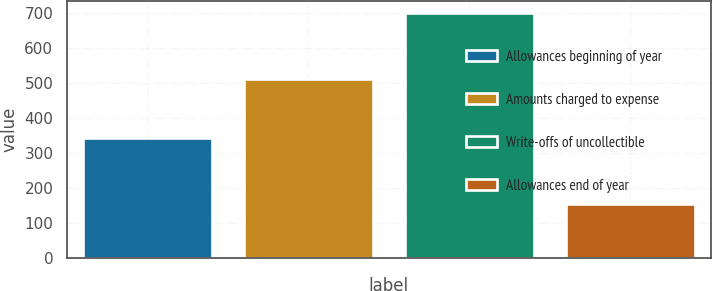Convert chart. <chart><loc_0><loc_0><loc_500><loc_500><bar_chart><fcel>Allowances beginning of year<fcel>Amounts charged to expense<fcel>Write-offs of uncollectible<fcel>Allowances end of year<nl><fcel>343<fcel>512<fcel>700<fcel>155<nl></chart> 